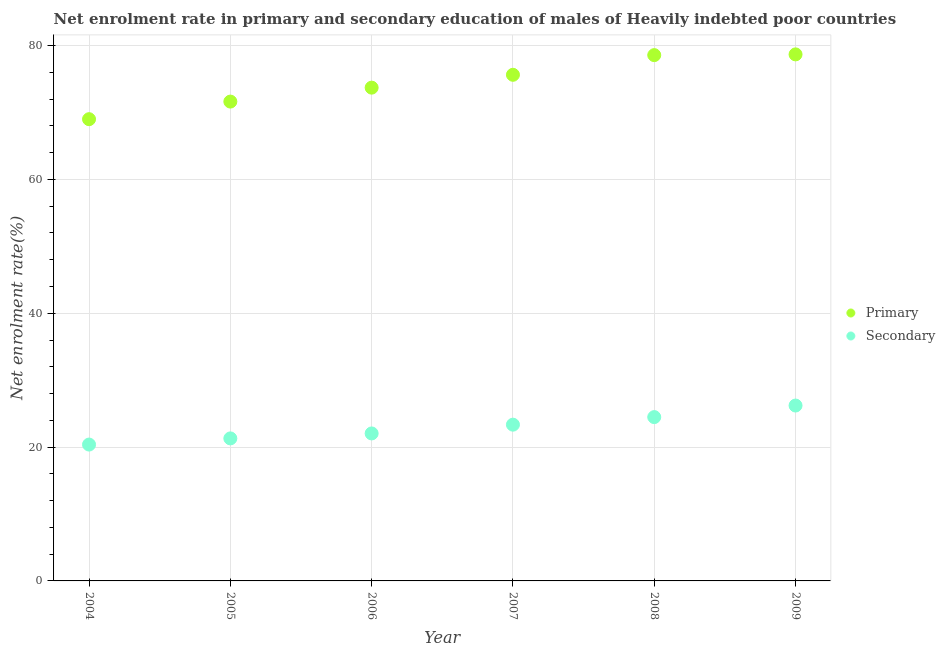How many different coloured dotlines are there?
Your response must be concise. 2. Is the number of dotlines equal to the number of legend labels?
Ensure brevity in your answer.  Yes. What is the enrollment rate in primary education in 2005?
Make the answer very short. 71.64. Across all years, what is the maximum enrollment rate in primary education?
Provide a short and direct response. 78.7. Across all years, what is the minimum enrollment rate in secondary education?
Offer a very short reply. 20.38. In which year was the enrollment rate in secondary education maximum?
Keep it short and to the point. 2009. What is the total enrollment rate in secondary education in the graph?
Your answer should be compact. 137.77. What is the difference between the enrollment rate in secondary education in 2004 and that in 2008?
Offer a very short reply. -4.1. What is the difference between the enrollment rate in secondary education in 2004 and the enrollment rate in primary education in 2009?
Give a very brief answer. -58.32. What is the average enrollment rate in secondary education per year?
Offer a terse response. 22.96. In the year 2005, what is the difference between the enrollment rate in secondary education and enrollment rate in primary education?
Offer a very short reply. -50.34. What is the ratio of the enrollment rate in primary education in 2004 to that in 2006?
Your answer should be compact. 0.94. What is the difference between the highest and the second highest enrollment rate in primary education?
Keep it short and to the point. 0.11. What is the difference between the highest and the lowest enrollment rate in secondary education?
Offer a very short reply. 5.83. In how many years, is the enrollment rate in secondary education greater than the average enrollment rate in secondary education taken over all years?
Provide a short and direct response. 3. Does the enrollment rate in primary education monotonically increase over the years?
Give a very brief answer. Yes. Is the enrollment rate in primary education strictly less than the enrollment rate in secondary education over the years?
Offer a very short reply. No. How many dotlines are there?
Offer a terse response. 2. Where does the legend appear in the graph?
Your answer should be very brief. Center right. What is the title of the graph?
Provide a short and direct response. Net enrolment rate in primary and secondary education of males of Heavily indebted poor countries. What is the label or title of the X-axis?
Make the answer very short. Year. What is the label or title of the Y-axis?
Your response must be concise. Net enrolment rate(%). What is the Net enrolment rate(%) in Primary in 2004?
Keep it short and to the point. 69.01. What is the Net enrolment rate(%) of Secondary in 2004?
Provide a short and direct response. 20.38. What is the Net enrolment rate(%) in Primary in 2005?
Your answer should be compact. 71.64. What is the Net enrolment rate(%) in Secondary in 2005?
Offer a very short reply. 21.3. What is the Net enrolment rate(%) in Primary in 2006?
Make the answer very short. 73.72. What is the Net enrolment rate(%) of Secondary in 2006?
Make the answer very short. 22.04. What is the Net enrolment rate(%) in Primary in 2007?
Your answer should be very brief. 75.65. What is the Net enrolment rate(%) in Secondary in 2007?
Your response must be concise. 23.35. What is the Net enrolment rate(%) of Primary in 2008?
Keep it short and to the point. 78.59. What is the Net enrolment rate(%) in Secondary in 2008?
Keep it short and to the point. 24.48. What is the Net enrolment rate(%) in Primary in 2009?
Keep it short and to the point. 78.7. What is the Net enrolment rate(%) in Secondary in 2009?
Ensure brevity in your answer.  26.21. Across all years, what is the maximum Net enrolment rate(%) of Primary?
Your answer should be very brief. 78.7. Across all years, what is the maximum Net enrolment rate(%) in Secondary?
Keep it short and to the point. 26.21. Across all years, what is the minimum Net enrolment rate(%) of Primary?
Ensure brevity in your answer.  69.01. Across all years, what is the minimum Net enrolment rate(%) of Secondary?
Offer a terse response. 20.38. What is the total Net enrolment rate(%) in Primary in the graph?
Give a very brief answer. 447.3. What is the total Net enrolment rate(%) in Secondary in the graph?
Your answer should be compact. 137.77. What is the difference between the Net enrolment rate(%) of Primary in 2004 and that in 2005?
Make the answer very short. -2.63. What is the difference between the Net enrolment rate(%) in Secondary in 2004 and that in 2005?
Keep it short and to the point. -0.92. What is the difference between the Net enrolment rate(%) of Primary in 2004 and that in 2006?
Offer a terse response. -4.71. What is the difference between the Net enrolment rate(%) in Secondary in 2004 and that in 2006?
Make the answer very short. -1.66. What is the difference between the Net enrolment rate(%) of Primary in 2004 and that in 2007?
Make the answer very short. -6.63. What is the difference between the Net enrolment rate(%) in Secondary in 2004 and that in 2007?
Provide a succinct answer. -2.97. What is the difference between the Net enrolment rate(%) of Primary in 2004 and that in 2008?
Ensure brevity in your answer.  -9.58. What is the difference between the Net enrolment rate(%) of Secondary in 2004 and that in 2008?
Your answer should be very brief. -4.1. What is the difference between the Net enrolment rate(%) in Primary in 2004 and that in 2009?
Keep it short and to the point. -9.69. What is the difference between the Net enrolment rate(%) in Secondary in 2004 and that in 2009?
Ensure brevity in your answer.  -5.83. What is the difference between the Net enrolment rate(%) in Primary in 2005 and that in 2006?
Make the answer very short. -2.08. What is the difference between the Net enrolment rate(%) of Secondary in 2005 and that in 2006?
Provide a short and direct response. -0.74. What is the difference between the Net enrolment rate(%) in Primary in 2005 and that in 2007?
Offer a terse response. -4. What is the difference between the Net enrolment rate(%) in Secondary in 2005 and that in 2007?
Keep it short and to the point. -2.05. What is the difference between the Net enrolment rate(%) of Primary in 2005 and that in 2008?
Keep it short and to the point. -6.95. What is the difference between the Net enrolment rate(%) of Secondary in 2005 and that in 2008?
Your answer should be very brief. -3.18. What is the difference between the Net enrolment rate(%) of Primary in 2005 and that in 2009?
Your answer should be compact. -7.05. What is the difference between the Net enrolment rate(%) in Secondary in 2005 and that in 2009?
Your answer should be compact. -4.91. What is the difference between the Net enrolment rate(%) of Primary in 2006 and that in 2007?
Ensure brevity in your answer.  -1.92. What is the difference between the Net enrolment rate(%) in Secondary in 2006 and that in 2007?
Your answer should be very brief. -1.31. What is the difference between the Net enrolment rate(%) in Primary in 2006 and that in 2008?
Your response must be concise. -4.86. What is the difference between the Net enrolment rate(%) in Secondary in 2006 and that in 2008?
Your response must be concise. -2.44. What is the difference between the Net enrolment rate(%) of Primary in 2006 and that in 2009?
Make the answer very short. -4.97. What is the difference between the Net enrolment rate(%) in Secondary in 2006 and that in 2009?
Ensure brevity in your answer.  -4.17. What is the difference between the Net enrolment rate(%) of Primary in 2007 and that in 2008?
Your answer should be very brief. -2.94. What is the difference between the Net enrolment rate(%) in Secondary in 2007 and that in 2008?
Your answer should be very brief. -1.13. What is the difference between the Net enrolment rate(%) of Primary in 2007 and that in 2009?
Your answer should be very brief. -3.05. What is the difference between the Net enrolment rate(%) in Secondary in 2007 and that in 2009?
Ensure brevity in your answer.  -2.86. What is the difference between the Net enrolment rate(%) of Primary in 2008 and that in 2009?
Offer a terse response. -0.11. What is the difference between the Net enrolment rate(%) of Secondary in 2008 and that in 2009?
Your answer should be very brief. -1.73. What is the difference between the Net enrolment rate(%) of Primary in 2004 and the Net enrolment rate(%) of Secondary in 2005?
Your answer should be very brief. 47.71. What is the difference between the Net enrolment rate(%) in Primary in 2004 and the Net enrolment rate(%) in Secondary in 2006?
Provide a short and direct response. 46.97. What is the difference between the Net enrolment rate(%) in Primary in 2004 and the Net enrolment rate(%) in Secondary in 2007?
Provide a short and direct response. 45.66. What is the difference between the Net enrolment rate(%) of Primary in 2004 and the Net enrolment rate(%) of Secondary in 2008?
Provide a succinct answer. 44.53. What is the difference between the Net enrolment rate(%) of Primary in 2004 and the Net enrolment rate(%) of Secondary in 2009?
Give a very brief answer. 42.8. What is the difference between the Net enrolment rate(%) of Primary in 2005 and the Net enrolment rate(%) of Secondary in 2006?
Your answer should be very brief. 49.6. What is the difference between the Net enrolment rate(%) in Primary in 2005 and the Net enrolment rate(%) in Secondary in 2007?
Provide a succinct answer. 48.29. What is the difference between the Net enrolment rate(%) in Primary in 2005 and the Net enrolment rate(%) in Secondary in 2008?
Offer a terse response. 47.16. What is the difference between the Net enrolment rate(%) of Primary in 2005 and the Net enrolment rate(%) of Secondary in 2009?
Give a very brief answer. 45.43. What is the difference between the Net enrolment rate(%) in Primary in 2006 and the Net enrolment rate(%) in Secondary in 2007?
Offer a terse response. 50.37. What is the difference between the Net enrolment rate(%) of Primary in 2006 and the Net enrolment rate(%) of Secondary in 2008?
Make the answer very short. 49.24. What is the difference between the Net enrolment rate(%) in Primary in 2006 and the Net enrolment rate(%) in Secondary in 2009?
Give a very brief answer. 47.51. What is the difference between the Net enrolment rate(%) in Primary in 2007 and the Net enrolment rate(%) in Secondary in 2008?
Offer a very short reply. 51.16. What is the difference between the Net enrolment rate(%) of Primary in 2007 and the Net enrolment rate(%) of Secondary in 2009?
Offer a very short reply. 49.43. What is the difference between the Net enrolment rate(%) in Primary in 2008 and the Net enrolment rate(%) in Secondary in 2009?
Provide a short and direct response. 52.37. What is the average Net enrolment rate(%) of Primary per year?
Give a very brief answer. 74.55. What is the average Net enrolment rate(%) in Secondary per year?
Your answer should be compact. 22.96. In the year 2004, what is the difference between the Net enrolment rate(%) of Primary and Net enrolment rate(%) of Secondary?
Offer a very short reply. 48.63. In the year 2005, what is the difference between the Net enrolment rate(%) in Primary and Net enrolment rate(%) in Secondary?
Make the answer very short. 50.34. In the year 2006, what is the difference between the Net enrolment rate(%) of Primary and Net enrolment rate(%) of Secondary?
Make the answer very short. 51.68. In the year 2007, what is the difference between the Net enrolment rate(%) of Primary and Net enrolment rate(%) of Secondary?
Keep it short and to the point. 52.29. In the year 2008, what is the difference between the Net enrolment rate(%) in Primary and Net enrolment rate(%) in Secondary?
Your answer should be very brief. 54.1. In the year 2009, what is the difference between the Net enrolment rate(%) in Primary and Net enrolment rate(%) in Secondary?
Your answer should be very brief. 52.48. What is the ratio of the Net enrolment rate(%) in Primary in 2004 to that in 2005?
Keep it short and to the point. 0.96. What is the ratio of the Net enrolment rate(%) in Secondary in 2004 to that in 2005?
Offer a very short reply. 0.96. What is the ratio of the Net enrolment rate(%) in Primary in 2004 to that in 2006?
Offer a very short reply. 0.94. What is the ratio of the Net enrolment rate(%) in Secondary in 2004 to that in 2006?
Keep it short and to the point. 0.92. What is the ratio of the Net enrolment rate(%) in Primary in 2004 to that in 2007?
Give a very brief answer. 0.91. What is the ratio of the Net enrolment rate(%) in Secondary in 2004 to that in 2007?
Keep it short and to the point. 0.87. What is the ratio of the Net enrolment rate(%) in Primary in 2004 to that in 2008?
Provide a succinct answer. 0.88. What is the ratio of the Net enrolment rate(%) in Secondary in 2004 to that in 2008?
Provide a succinct answer. 0.83. What is the ratio of the Net enrolment rate(%) in Primary in 2004 to that in 2009?
Give a very brief answer. 0.88. What is the ratio of the Net enrolment rate(%) in Secondary in 2004 to that in 2009?
Provide a short and direct response. 0.78. What is the ratio of the Net enrolment rate(%) of Primary in 2005 to that in 2006?
Your answer should be compact. 0.97. What is the ratio of the Net enrolment rate(%) of Secondary in 2005 to that in 2006?
Provide a short and direct response. 0.97. What is the ratio of the Net enrolment rate(%) of Primary in 2005 to that in 2007?
Your answer should be very brief. 0.95. What is the ratio of the Net enrolment rate(%) of Secondary in 2005 to that in 2007?
Make the answer very short. 0.91. What is the ratio of the Net enrolment rate(%) in Primary in 2005 to that in 2008?
Make the answer very short. 0.91. What is the ratio of the Net enrolment rate(%) in Secondary in 2005 to that in 2008?
Your answer should be very brief. 0.87. What is the ratio of the Net enrolment rate(%) in Primary in 2005 to that in 2009?
Ensure brevity in your answer.  0.91. What is the ratio of the Net enrolment rate(%) in Secondary in 2005 to that in 2009?
Your answer should be very brief. 0.81. What is the ratio of the Net enrolment rate(%) of Primary in 2006 to that in 2007?
Your answer should be compact. 0.97. What is the ratio of the Net enrolment rate(%) of Secondary in 2006 to that in 2007?
Ensure brevity in your answer.  0.94. What is the ratio of the Net enrolment rate(%) in Primary in 2006 to that in 2008?
Keep it short and to the point. 0.94. What is the ratio of the Net enrolment rate(%) in Secondary in 2006 to that in 2008?
Provide a short and direct response. 0.9. What is the ratio of the Net enrolment rate(%) of Primary in 2006 to that in 2009?
Give a very brief answer. 0.94. What is the ratio of the Net enrolment rate(%) in Secondary in 2006 to that in 2009?
Ensure brevity in your answer.  0.84. What is the ratio of the Net enrolment rate(%) of Primary in 2007 to that in 2008?
Your response must be concise. 0.96. What is the ratio of the Net enrolment rate(%) of Secondary in 2007 to that in 2008?
Your answer should be very brief. 0.95. What is the ratio of the Net enrolment rate(%) in Primary in 2007 to that in 2009?
Keep it short and to the point. 0.96. What is the ratio of the Net enrolment rate(%) in Secondary in 2007 to that in 2009?
Offer a terse response. 0.89. What is the ratio of the Net enrolment rate(%) of Primary in 2008 to that in 2009?
Provide a short and direct response. 1. What is the ratio of the Net enrolment rate(%) of Secondary in 2008 to that in 2009?
Ensure brevity in your answer.  0.93. What is the difference between the highest and the second highest Net enrolment rate(%) in Primary?
Offer a terse response. 0.11. What is the difference between the highest and the second highest Net enrolment rate(%) of Secondary?
Your response must be concise. 1.73. What is the difference between the highest and the lowest Net enrolment rate(%) in Primary?
Provide a short and direct response. 9.69. What is the difference between the highest and the lowest Net enrolment rate(%) in Secondary?
Give a very brief answer. 5.83. 